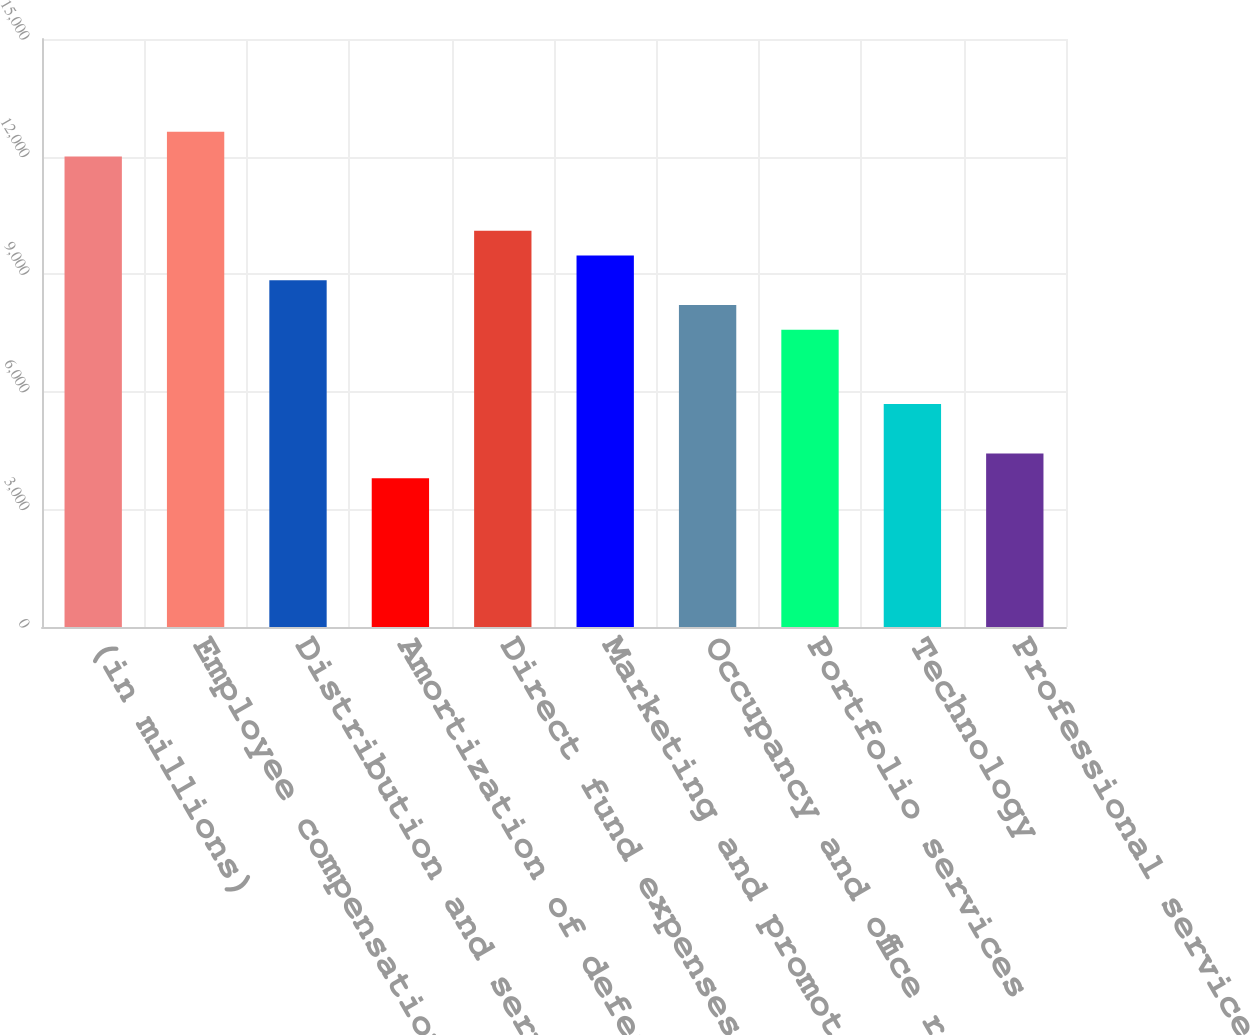Convert chart to OTSL. <chart><loc_0><loc_0><loc_500><loc_500><bar_chart><fcel>(in millions)<fcel>Employee compensation and<fcel>Distribution and servicing<fcel>Amortization of deferred sales<fcel>Direct fund expenses<fcel>Marketing and promotional<fcel>Occupancy and office related<fcel>Portfolio services<fcel>Technology<fcel>Professional services<nl><fcel>12004.7<fcel>12636<fcel>8848.2<fcel>3797.8<fcel>10110.8<fcel>9479.5<fcel>8216.9<fcel>7585.6<fcel>5691.7<fcel>4429.1<nl></chart> 